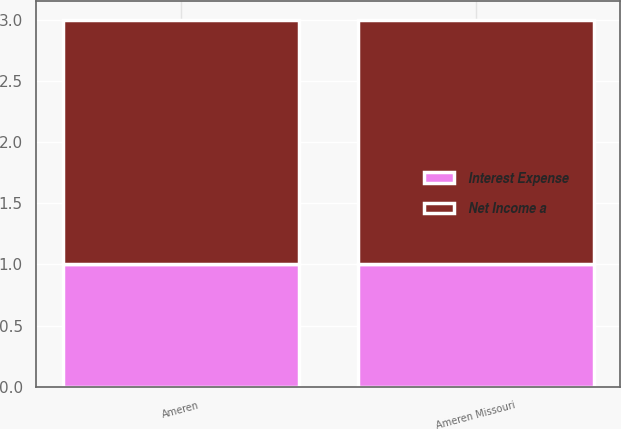Convert chart. <chart><loc_0><loc_0><loc_500><loc_500><stacked_bar_chart><ecel><fcel>Ameren<fcel>Ameren Missouri<nl><fcel>Net Income a<fcel>2<fcel>2<nl><fcel>Interest Expense<fcel>1<fcel>1<nl></chart> 